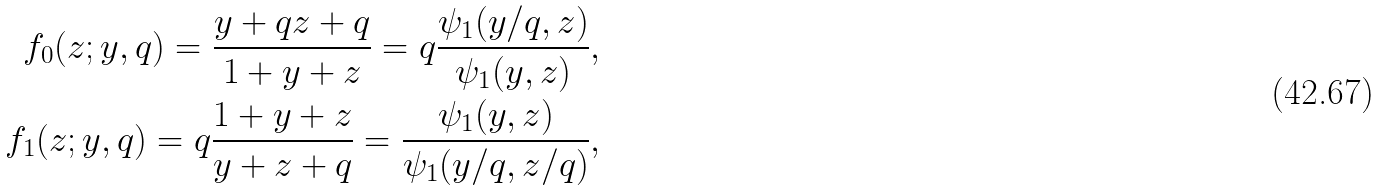<formula> <loc_0><loc_0><loc_500><loc_500>f _ { 0 } ( z ; y , q ) = \frac { y + q z + q } { 1 + y + z } = q \frac { \psi _ { 1 } ( y / q , z ) } { \psi _ { 1 } ( y , z ) } , \\ f _ { 1 } ( z ; y , q ) = q \frac { 1 + y + z } { y + z + q } = \frac { \psi _ { 1 } ( y , z ) } { \psi _ { 1 } ( y / q , z / q ) } ,</formula> 